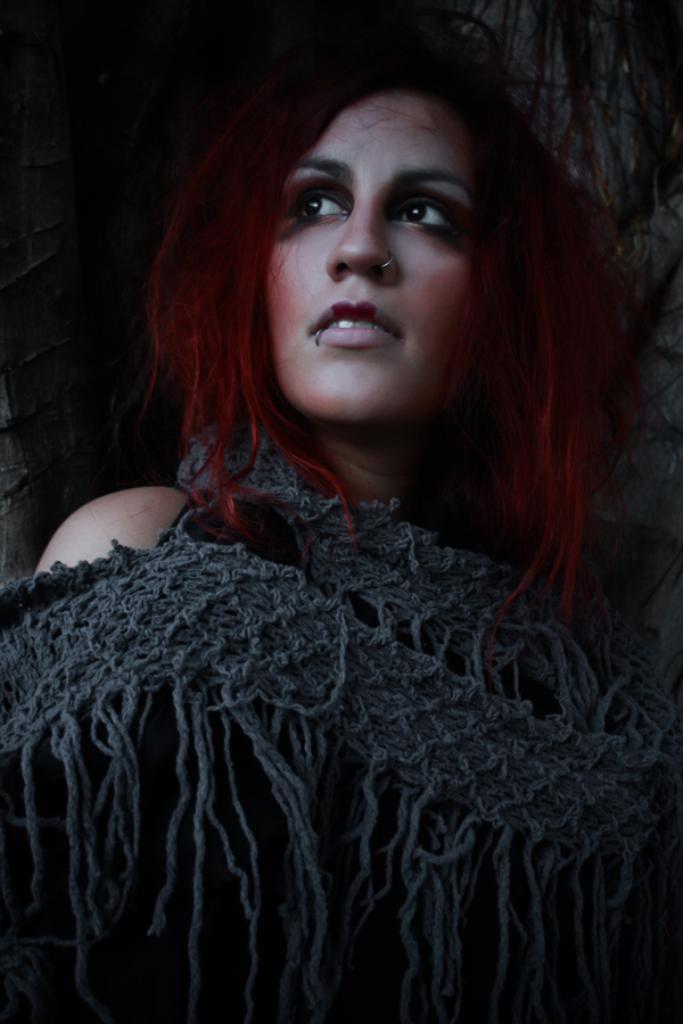What is the main subject of the image? The main subject of the image is a woman. What type of kite is the woman flying in the image? There is no kite present in the image; it only features a woman. 